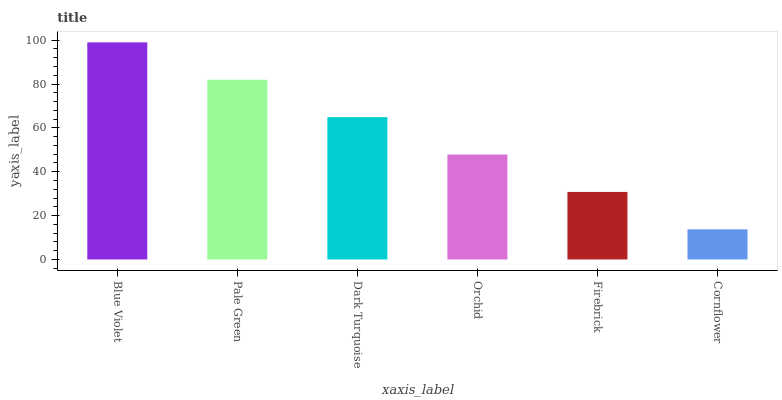Is Cornflower the minimum?
Answer yes or no. Yes. Is Blue Violet the maximum?
Answer yes or no. Yes. Is Pale Green the minimum?
Answer yes or no. No. Is Pale Green the maximum?
Answer yes or no. No. Is Blue Violet greater than Pale Green?
Answer yes or no. Yes. Is Pale Green less than Blue Violet?
Answer yes or no. Yes. Is Pale Green greater than Blue Violet?
Answer yes or no. No. Is Blue Violet less than Pale Green?
Answer yes or no. No. Is Dark Turquoise the high median?
Answer yes or no. Yes. Is Orchid the low median?
Answer yes or no. Yes. Is Firebrick the high median?
Answer yes or no. No. Is Pale Green the low median?
Answer yes or no. No. 